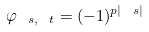<formula> <loc_0><loc_0><loc_500><loc_500>\varphi _ { \ s , \ t } = ( - 1 ) ^ { p | \ s | }</formula> 